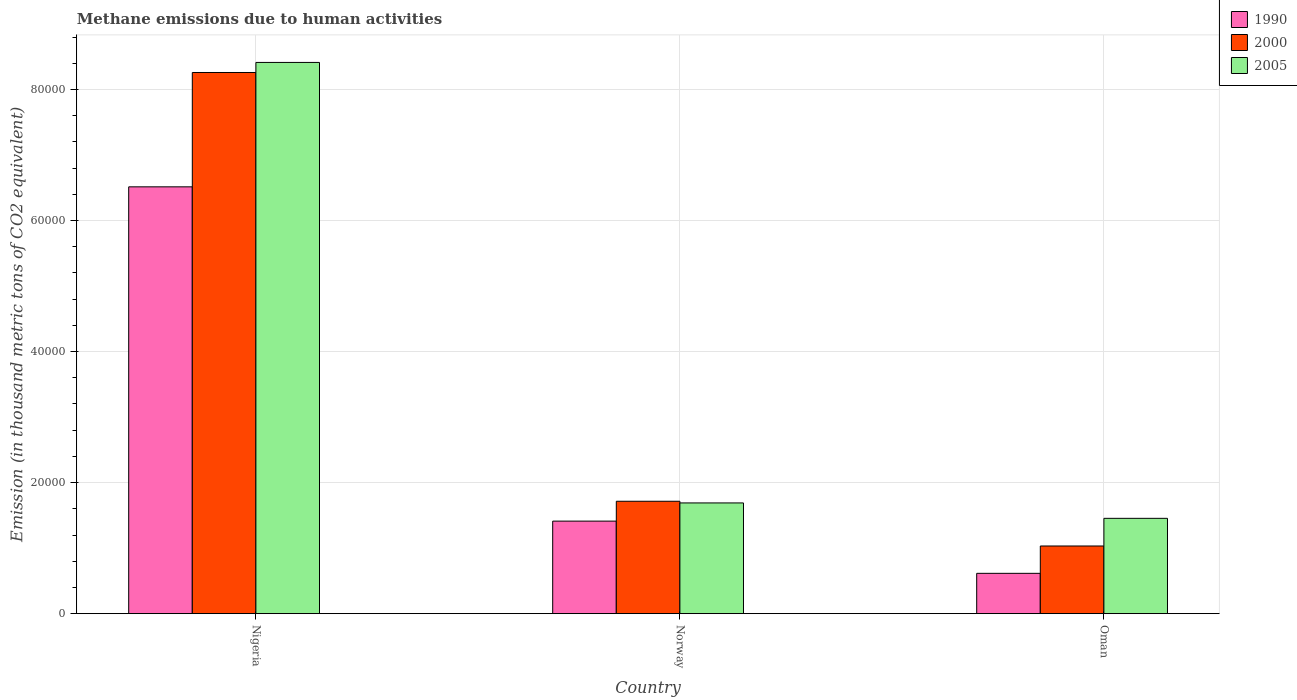Are the number of bars per tick equal to the number of legend labels?
Offer a very short reply. Yes. Are the number of bars on each tick of the X-axis equal?
Offer a very short reply. Yes. How many bars are there on the 1st tick from the left?
Your response must be concise. 3. What is the label of the 2nd group of bars from the left?
Make the answer very short. Norway. What is the amount of methane emitted in 2000 in Norway?
Give a very brief answer. 1.72e+04. Across all countries, what is the maximum amount of methane emitted in 2000?
Your response must be concise. 8.26e+04. Across all countries, what is the minimum amount of methane emitted in 2005?
Your response must be concise. 1.45e+04. In which country was the amount of methane emitted in 2000 maximum?
Ensure brevity in your answer.  Nigeria. In which country was the amount of methane emitted in 1990 minimum?
Your response must be concise. Oman. What is the total amount of methane emitted in 2000 in the graph?
Keep it short and to the point. 1.10e+05. What is the difference between the amount of methane emitted in 2005 in Nigeria and that in Oman?
Provide a succinct answer. 6.96e+04. What is the difference between the amount of methane emitted in 2000 in Oman and the amount of methane emitted in 2005 in Nigeria?
Give a very brief answer. -7.38e+04. What is the average amount of methane emitted in 2005 per country?
Offer a very short reply. 3.85e+04. What is the difference between the amount of methane emitted of/in 2000 and amount of methane emitted of/in 1990 in Norway?
Offer a very short reply. 3029.8. What is the ratio of the amount of methane emitted in 1990 in Nigeria to that in Norway?
Your answer should be compact. 4.61. Is the amount of methane emitted in 2005 in Nigeria less than that in Norway?
Offer a very short reply. No. What is the difference between the highest and the second highest amount of methane emitted in 2005?
Give a very brief answer. 2350.8. What is the difference between the highest and the lowest amount of methane emitted in 1990?
Offer a very short reply. 5.90e+04. Is the sum of the amount of methane emitted in 1990 in Norway and Oman greater than the maximum amount of methane emitted in 2005 across all countries?
Ensure brevity in your answer.  No. What does the 3rd bar from the left in Norway represents?
Give a very brief answer. 2005. Is it the case that in every country, the sum of the amount of methane emitted in 2000 and amount of methane emitted in 1990 is greater than the amount of methane emitted in 2005?
Your response must be concise. Yes. How many bars are there?
Your answer should be compact. 9. How many countries are there in the graph?
Give a very brief answer. 3. Are the values on the major ticks of Y-axis written in scientific E-notation?
Keep it short and to the point. No. Does the graph contain any zero values?
Provide a short and direct response. No. Does the graph contain grids?
Offer a terse response. Yes. How many legend labels are there?
Make the answer very short. 3. What is the title of the graph?
Your answer should be compact. Methane emissions due to human activities. What is the label or title of the X-axis?
Your answer should be very brief. Country. What is the label or title of the Y-axis?
Keep it short and to the point. Emission (in thousand metric tons of CO2 equivalent). What is the Emission (in thousand metric tons of CO2 equivalent) of 1990 in Nigeria?
Ensure brevity in your answer.  6.51e+04. What is the Emission (in thousand metric tons of CO2 equivalent) of 2000 in Nigeria?
Give a very brief answer. 8.26e+04. What is the Emission (in thousand metric tons of CO2 equivalent) in 2005 in Nigeria?
Your answer should be compact. 8.41e+04. What is the Emission (in thousand metric tons of CO2 equivalent) in 1990 in Norway?
Make the answer very short. 1.41e+04. What is the Emission (in thousand metric tons of CO2 equivalent) in 2000 in Norway?
Make the answer very short. 1.72e+04. What is the Emission (in thousand metric tons of CO2 equivalent) in 2005 in Norway?
Provide a short and direct response. 1.69e+04. What is the Emission (in thousand metric tons of CO2 equivalent) in 1990 in Oman?
Give a very brief answer. 6152.9. What is the Emission (in thousand metric tons of CO2 equivalent) of 2000 in Oman?
Ensure brevity in your answer.  1.03e+04. What is the Emission (in thousand metric tons of CO2 equivalent) in 2005 in Oman?
Your answer should be very brief. 1.45e+04. Across all countries, what is the maximum Emission (in thousand metric tons of CO2 equivalent) in 1990?
Ensure brevity in your answer.  6.51e+04. Across all countries, what is the maximum Emission (in thousand metric tons of CO2 equivalent) of 2000?
Offer a very short reply. 8.26e+04. Across all countries, what is the maximum Emission (in thousand metric tons of CO2 equivalent) of 2005?
Make the answer very short. 8.41e+04. Across all countries, what is the minimum Emission (in thousand metric tons of CO2 equivalent) in 1990?
Offer a very short reply. 6152.9. Across all countries, what is the minimum Emission (in thousand metric tons of CO2 equivalent) in 2000?
Provide a succinct answer. 1.03e+04. Across all countries, what is the minimum Emission (in thousand metric tons of CO2 equivalent) in 2005?
Your answer should be compact. 1.45e+04. What is the total Emission (in thousand metric tons of CO2 equivalent) of 1990 in the graph?
Make the answer very short. 8.54e+04. What is the total Emission (in thousand metric tons of CO2 equivalent) in 2000 in the graph?
Make the answer very short. 1.10e+05. What is the total Emission (in thousand metric tons of CO2 equivalent) in 2005 in the graph?
Give a very brief answer. 1.16e+05. What is the difference between the Emission (in thousand metric tons of CO2 equivalent) of 1990 in Nigeria and that in Norway?
Offer a terse response. 5.10e+04. What is the difference between the Emission (in thousand metric tons of CO2 equivalent) of 2000 in Nigeria and that in Norway?
Provide a short and direct response. 6.54e+04. What is the difference between the Emission (in thousand metric tons of CO2 equivalent) in 2005 in Nigeria and that in Norway?
Your answer should be very brief. 6.72e+04. What is the difference between the Emission (in thousand metric tons of CO2 equivalent) in 1990 in Nigeria and that in Oman?
Ensure brevity in your answer.  5.90e+04. What is the difference between the Emission (in thousand metric tons of CO2 equivalent) in 2000 in Nigeria and that in Oman?
Provide a short and direct response. 7.23e+04. What is the difference between the Emission (in thousand metric tons of CO2 equivalent) in 2005 in Nigeria and that in Oman?
Offer a terse response. 6.96e+04. What is the difference between the Emission (in thousand metric tons of CO2 equivalent) in 1990 in Norway and that in Oman?
Give a very brief answer. 7969. What is the difference between the Emission (in thousand metric tons of CO2 equivalent) in 2000 in Norway and that in Oman?
Your answer should be compact. 6825.4. What is the difference between the Emission (in thousand metric tons of CO2 equivalent) of 2005 in Norway and that in Oman?
Offer a very short reply. 2350.8. What is the difference between the Emission (in thousand metric tons of CO2 equivalent) in 1990 in Nigeria and the Emission (in thousand metric tons of CO2 equivalent) in 2000 in Norway?
Your answer should be very brief. 4.80e+04. What is the difference between the Emission (in thousand metric tons of CO2 equivalent) in 1990 in Nigeria and the Emission (in thousand metric tons of CO2 equivalent) in 2005 in Norway?
Provide a succinct answer. 4.82e+04. What is the difference between the Emission (in thousand metric tons of CO2 equivalent) of 2000 in Nigeria and the Emission (in thousand metric tons of CO2 equivalent) of 2005 in Norway?
Give a very brief answer. 6.57e+04. What is the difference between the Emission (in thousand metric tons of CO2 equivalent) in 1990 in Nigeria and the Emission (in thousand metric tons of CO2 equivalent) in 2000 in Oman?
Offer a terse response. 5.48e+04. What is the difference between the Emission (in thousand metric tons of CO2 equivalent) of 1990 in Nigeria and the Emission (in thousand metric tons of CO2 equivalent) of 2005 in Oman?
Offer a terse response. 5.06e+04. What is the difference between the Emission (in thousand metric tons of CO2 equivalent) of 2000 in Nigeria and the Emission (in thousand metric tons of CO2 equivalent) of 2005 in Oman?
Provide a succinct answer. 6.80e+04. What is the difference between the Emission (in thousand metric tons of CO2 equivalent) in 1990 in Norway and the Emission (in thousand metric tons of CO2 equivalent) in 2000 in Oman?
Provide a short and direct response. 3795.6. What is the difference between the Emission (in thousand metric tons of CO2 equivalent) of 1990 in Norway and the Emission (in thousand metric tons of CO2 equivalent) of 2005 in Oman?
Ensure brevity in your answer.  -424.2. What is the difference between the Emission (in thousand metric tons of CO2 equivalent) of 2000 in Norway and the Emission (in thousand metric tons of CO2 equivalent) of 2005 in Oman?
Keep it short and to the point. 2605.6. What is the average Emission (in thousand metric tons of CO2 equivalent) of 1990 per country?
Offer a terse response. 2.85e+04. What is the average Emission (in thousand metric tons of CO2 equivalent) in 2000 per country?
Provide a succinct answer. 3.67e+04. What is the average Emission (in thousand metric tons of CO2 equivalent) of 2005 per country?
Keep it short and to the point. 3.85e+04. What is the difference between the Emission (in thousand metric tons of CO2 equivalent) in 1990 and Emission (in thousand metric tons of CO2 equivalent) in 2000 in Nigeria?
Make the answer very short. -1.75e+04. What is the difference between the Emission (in thousand metric tons of CO2 equivalent) in 1990 and Emission (in thousand metric tons of CO2 equivalent) in 2005 in Nigeria?
Ensure brevity in your answer.  -1.90e+04. What is the difference between the Emission (in thousand metric tons of CO2 equivalent) in 2000 and Emission (in thousand metric tons of CO2 equivalent) in 2005 in Nigeria?
Offer a very short reply. -1533.6. What is the difference between the Emission (in thousand metric tons of CO2 equivalent) in 1990 and Emission (in thousand metric tons of CO2 equivalent) in 2000 in Norway?
Offer a terse response. -3029.8. What is the difference between the Emission (in thousand metric tons of CO2 equivalent) of 1990 and Emission (in thousand metric tons of CO2 equivalent) of 2005 in Norway?
Your answer should be very brief. -2775. What is the difference between the Emission (in thousand metric tons of CO2 equivalent) in 2000 and Emission (in thousand metric tons of CO2 equivalent) in 2005 in Norway?
Make the answer very short. 254.8. What is the difference between the Emission (in thousand metric tons of CO2 equivalent) in 1990 and Emission (in thousand metric tons of CO2 equivalent) in 2000 in Oman?
Your answer should be very brief. -4173.4. What is the difference between the Emission (in thousand metric tons of CO2 equivalent) of 1990 and Emission (in thousand metric tons of CO2 equivalent) of 2005 in Oman?
Ensure brevity in your answer.  -8393.2. What is the difference between the Emission (in thousand metric tons of CO2 equivalent) in 2000 and Emission (in thousand metric tons of CO2 equivalent) in 2005 in Oman?
Provide a short and direct response. -4219.8. What is the ratio of the Emission (in thousand metric tons of CO2 equivalent) of 1990 in Nigeria to that in Norway?
Give a very brief answer. 4.61. What is the ratio of the Emission (in thousand metric tons of CO2 equivalent) in 2000 in Nigeria to that in Norway?
Ensure brevity in your answer.  4.82. What is the ratio of the Emission (in thousand metric tons of CO2 equivalent) of 2005 in Nigeria to that in Norway?
Make the answer very short. 4.98. What is the ratio of the Emission (in thousand metric tons of CO2 equivalent) of 1990 in Nigeria to that in Oman?
Make the answer very short. 10.59. What is the ratio of the Emission (in thousand metric tons of CO2 equivalent) of 2000 in Nigeria to that in Oman?
Your response must be concise. 8. What is the ratio of the Emission (in thousand metric tons of CO2 equivalent) in 2005 in Nigeria to that in Oman?
Ensure brevity in your answer.  5.78. What is the ratio of the Emission (in thousand metric tons of CO2 equivalent) in 1990 in Norway to that in Oman?
Keep it short and to the point. 2.3. What is the ratio of the Emission (in thousand metric tons of CO2 equivalent) in 2000 in Norway to that in Oman?
Ensure brevity in your answer.  1.66. What is the ratio of the Emission (in thousand metric tons of CO2 equivalent) of 2005 in Norway to that in Oman?
Your answer should be compact. 1.16. What is the difference between the highest and the second highest Emission (in thousand metric tons of CO2 equivalent) in 1990?
Give a very brief answer. 5.10e+04. What is the difference between the highest and the second highest Emission (in thousand metric tons of CO2 equivalent) of 2000?
Provide a succinct answer. 6.54e+04. What is the difference between the highest and the second highest Emission (in thousand metric tons of CO2 equivalent) in 2005?
Keep it short and to the point. 6.72e+04. What is the difference between the highest and the lowest Emission (in thousand metric tons of CO2 equivalent) of 1990?
Offer a terse response. 5.90e+04. What is the difference between the highest and the lowest Emission (in thousand metric tons of CO2 equivalent) of 2000?
Offer a very short reply. 7.23e+04. What is the difference between the highest and the lowest Emission (in thousand metric tons of CO2 equivalent) of 2005?
Provide a short and direct response. 6.96e+04. 